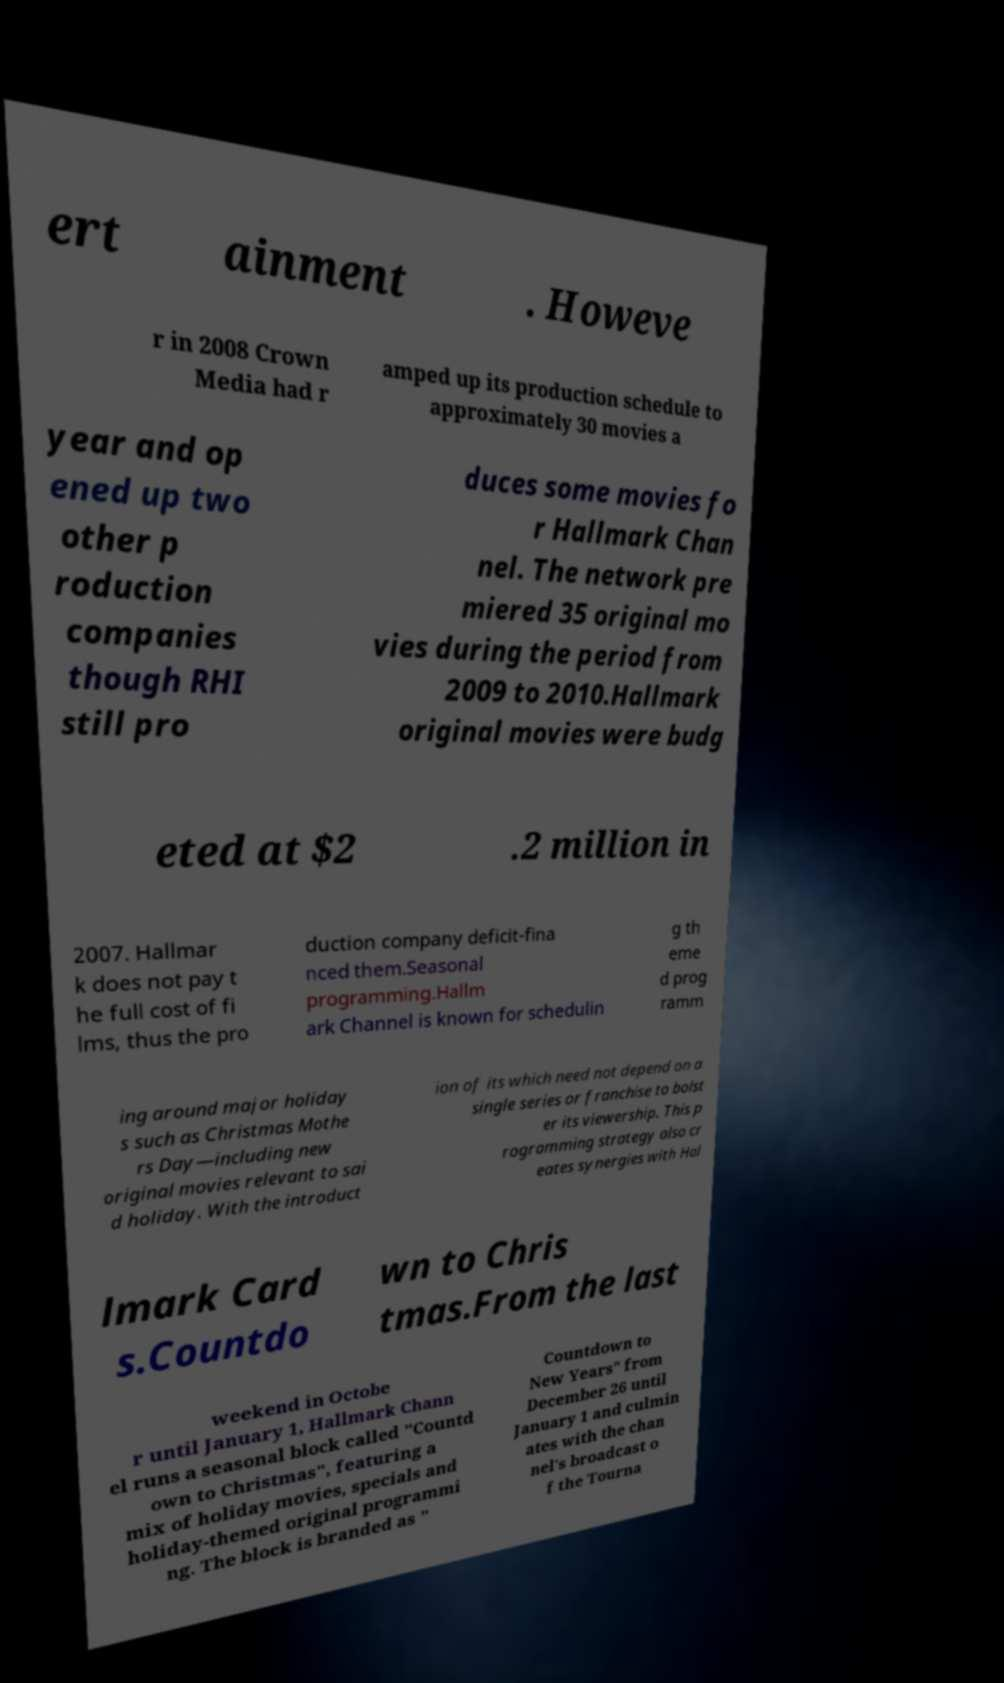What messages or text are displayed in this image? I need them in a readable, typed format. ert ainment . Howeve r in 2008 Crown Media had r amped up its production schedule to approximately 30 movies a year and op ened up two other p roduction companies though RHI still pro duces some movies fo r Hallmark Chan nel. The network pre miered 35 original mo vies during the period from 2009 to 2010.Hallmark original movies were budg eted at $2 .2 million in 2007. Hallmar k does not pay t he full cost of fi lms, thus the pro duction company deficit-fina nced them.Seasonal programming.Hallm ark Channel is known for schedulin g th eme d prog ramm ing around major holiday s such as Christmas Mothe rs Day—including new original movies relevant to sai d holiday. With the introduct ion of its which need not depend on a single series or franchise to bolst er its viewership. This p rogramming strategy also cr eates synergies with Hal lmark Card s.Countdo wn to Chris tmas.From the last weekend in Octobe r until January 1, Hallmark Chann el runs a seasonal block called "Countd own to Christmas", featuring a mix of holiday movies, specials and holiday-themed original programmi ng. The block is branded as " Countdown to New Years" from December 26 until January 1 and culmin ates with the chan nel's broadcast o f the Tourna 